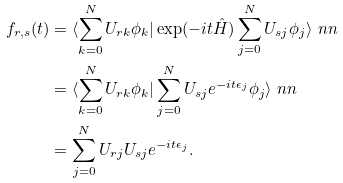<formula> <loc_0><loc_0><loc_500><loc_500>f _ { r , s } ( t ) & = \langle \sum _ { k = 0 } ^ { N } U _ { r k } \phi _ { k } | \exp ( - i t \hat { H } ) \sum _ { j = 0 } ^ { N } U _ { s j } \phi _ { j } \rangle \ n n \\ & = \langle \sum _ { k = 0 } ^ { N } U _ { r k } \phi _ { k } | \sum _ { j = 0 } ^ { N } U _ { s j } e ^ { - i t \epsilon _ { j } } \phi _ { j } \rangle \ n n \\ & = \sum _ { j = 0 } ^ { N } U _ { r j } U _ { s j } e ^ { - i t \epsilon _ { j } } .</formula> 